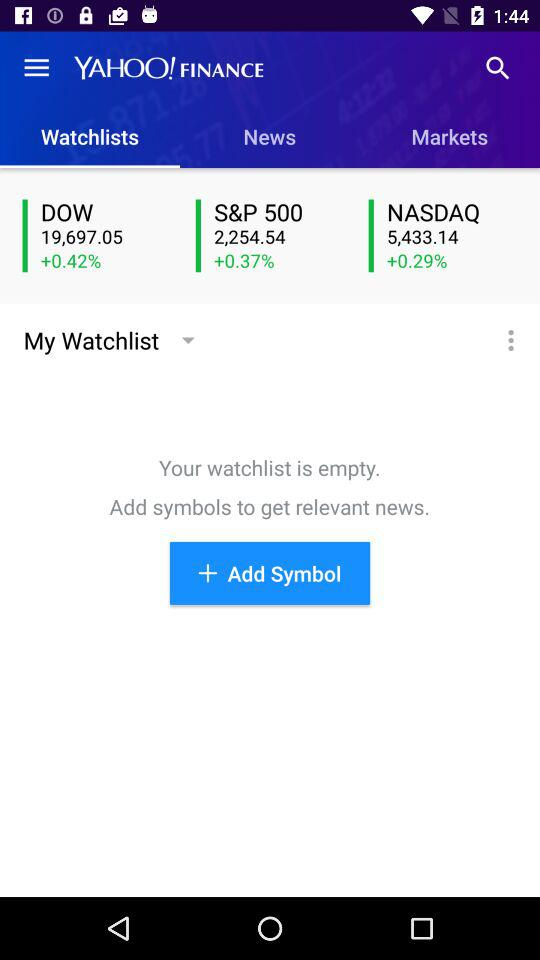What is the application name? The application name is "YAHOO!FINANCE". 